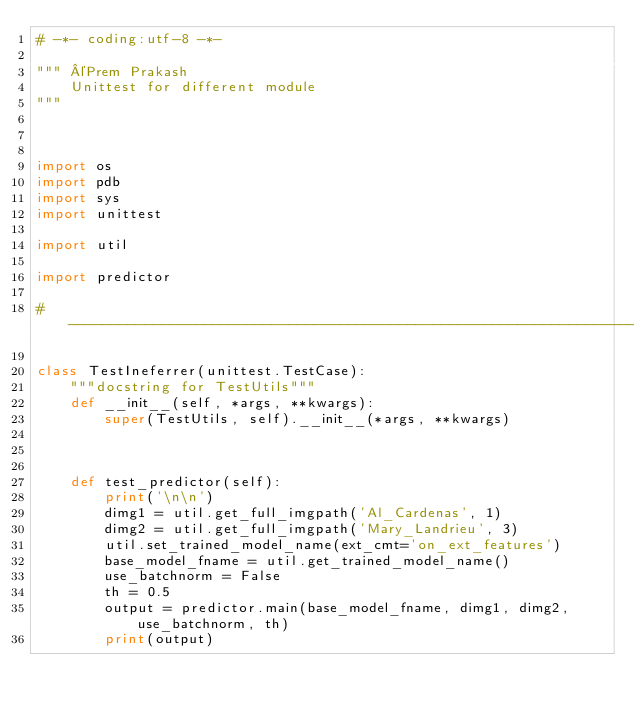Convert code to text. <code><loc_0><loc_0><loc_500><loc_500><_Python_># -*- coding:utf-8 -*-

""" ©Prem Prakash
	Unittest for different module
"""



import os
import pdb
import sys
import unittest

import util

import predictor

#----------------------------------------------------------------------------

class TestIneferrer(unittest.TestCase):
	"""docstring for TestUtils"""
	def __init__(self, *args, **kwargs):
		super(TestUtils, self).__init__(*args, **kwargs)
		
		
	
	def test_predictor(self):
		print('\n\n')
		dimg1 = util.get_full_imgpath('Al_Cardenas', 1)
		dimg2 = util.get_full_imgpath('Mary_Landrieu', 3)
		util.set_trained_model_name(ext_cmt='on_ext_features')
		base_model_fname = util.get_trained_model_name()
		use_batchnorm = False
		th = 0.5
		output = predictor.main(base_model_fname, dimg1, dimg2, use_batchnorm, th)
		print(output)</code> 